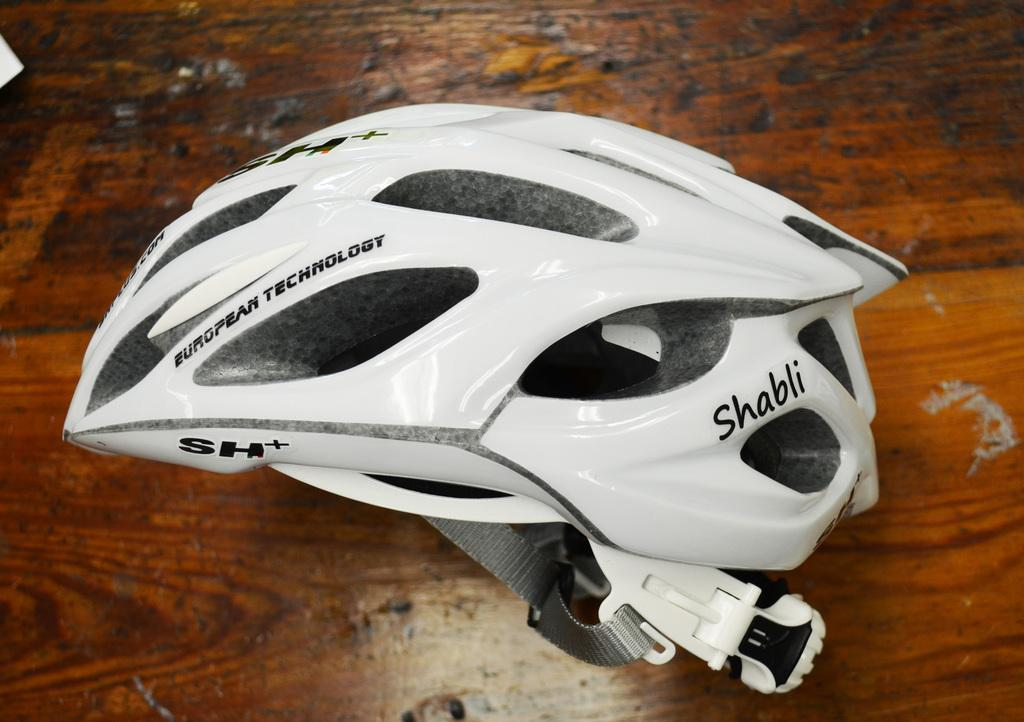What piece of furniture is present in the image? There is a table in the image. What object is placed on the table? There is a white color helmet on the table. Where is the judge sitting in the image? There is no judge present in the image. What type of throne is visible in the image? There is no throne present in the image. 